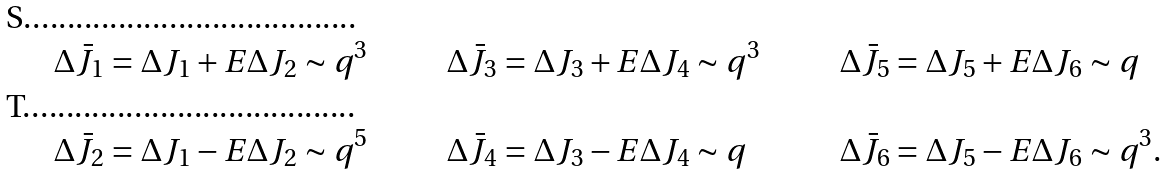<formula> <loc_0><loc_0><loc_500><loc_500>\Delta \bar { J } _ { 1 } & = \Delta J _ { 1 } + E \Delta J _ { 2 } \sim q ^ { 3 } \quad & \Delta \bar { J } _ { 3 } & = \Delta J _ { 3 } + E \Delta J _ { 4 } \sim q ^ { 3 } \quad & \Delta \bar { J } _ { 5 } & = \Delta J _ { 5 } + E \Delta J _ { 6 } \sim q \\ \Delta \bar { J } _ { 2 } & = \Delta J _ { 1 } - E \Delta J _ { 2 } \sim q ^ { 5 } \quad & \Delta \bar { J } _ { 4 } & = \Delta J _ { 3 } - E \Delta J _ { 4 } \sim q \quad & \Delta \bar { J } _ { 6 } & = \Delta J _ { 5 } - E \Delta J _ { 6 } \sim q ^ { 3 } .</formula> 